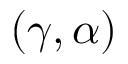<formula> <loc_0><loc_0><loc_500><loc_500>( \gamma , \alpha )</formula> 